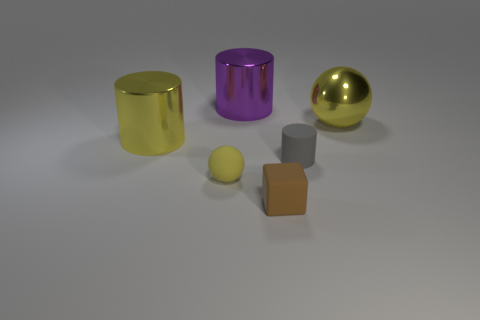There is a cylinder that is made of the same material as the small brown thing; what is its size?
Your response must be concise. Small. Are there more big cyan rubber balls than small brown cubes?
Make the answer very short. No. There is a thing in front of the matte ball; what color is it?
Provide a short and direct response. Brown. There is a object that is both behind the small rubber cylinder and to the right of the brown object; what size is it?
Your answer should be compact. Large. How many brown things have the same size as the cube?
Offer a very short reply. 0. There is a purple object that is the same shape as the small gray thing; what material is it?
Offer a very short reply. Metal. Does the purple shiny object have the same shape as the tiny brown object?
Your response must be concise. No. How many large metallic cylinders are on the left side of the yellow rubber thing?
Provide a succinct answer. 1. There is a gray matte object in front of the large metallic object on the left side of the tiny yellow sphere; what is its shape?
Give a very brief answer. Cylinder. What is the shape of the gray thing that is made of the same material as the small brown object?
Offer a terse response. Cylinder. 